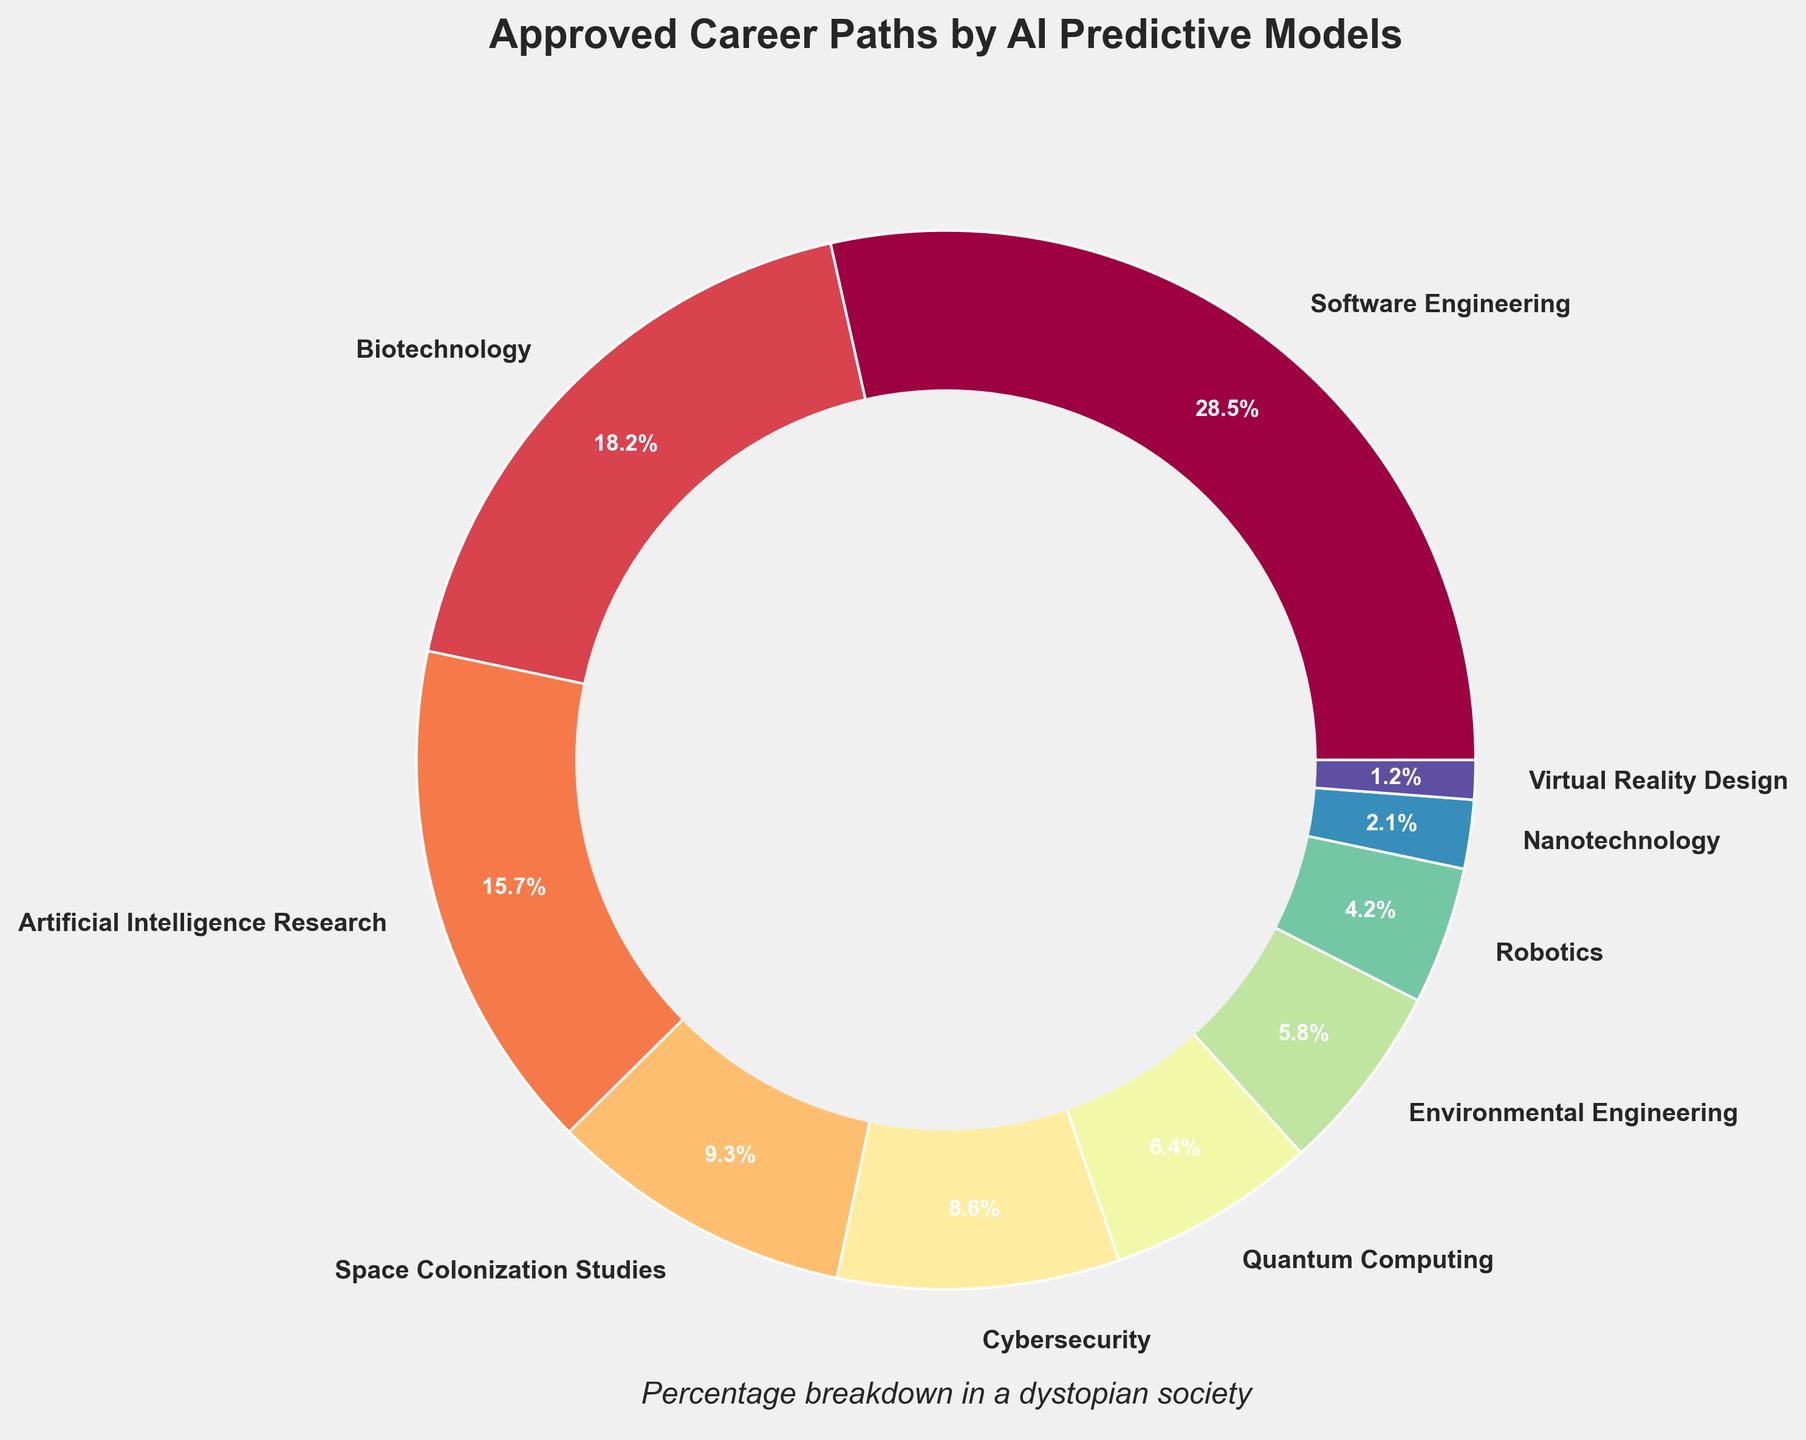What percentage of approved career paths is dedicated to the areas directly involving future technology (AI Research, Space Colonization Studies, Quantum Computing, Nanotechnology, and Robotics)? Sum the percentages for the specific career paths: Artificial Intelligence Research (15.7), Space Colonization Studies (9.3), Quantum Computing (6.4), Nanotechnology (2.1), and Robotics (4.2). 15.7 + 9.3 + 6.4 + 2.1 + 4.2 = 37.7%
Answer: 37.7% Which career path has the highest approval percentage? Identify the career path with the highest percentage value from the pie chart. Software Engineering has the highest percentage at 28.5%
Answer: Software Engineering Compare the combined percentage of careers in Biotechnology and Environmental Engineering to those in Quantum Computing and Virtual Reality Design. Which combined group has a higher percentage? Calculate the sum of percentages for both groups: Biotechnology (18.2) + Environmental Engineering (5.8) = 24%; Quantum Computing (6.4) + Virtual Reality Design (1.2) = 7.6%; 24% > 7.6%, so the combined percentage of Biotechnology and Environmental Engineering is higher
Answer: Biotechnology and Environmental Engineering Is the percentage for Cybersecurity greater than the combined percentage for Nanotechnology and Virtual Reality Design? Compare the percentages: Cybersecurity (8.6) is greater than the combined percentage of Nanotechnology (2.1) and Virtual Reality Design (1.2), which totals 3.3%. 8.6 > 3.3
Answer: Yes What is the difference in approval percentages between the top approved career path and the least approved career path? Subtract the percentage of the least approved career path (Virtual Reality Design at 1.2%) from the top approved career path (Software Engineering at 28.5%). 28.5 - 1.2 = 27.3
Answer: 27.3 Which career path categories are represented by the smallest and largest wedges in the pie chart in terms of visual area? The smallest and largest wedges correspond to the career paths with the smallest and largest percentages respectively. The largest wedge is Software Engineering (28.5%), and the smallest wedge is Virtual Reality Design (1.2%)
Answer: Software Engineering and Virtual Reality Design What is the average approval percentage for all the career paths presented? Sum all career path percentages and divide by the number of career paths. (28.5 + 18.2 + 15.7 + 9.3 + 8.6 + 6.4 + 5.8 + 4.2 + 2.1 + 1.2) / 10 = 100 / 10 = 10
Answer: 10 